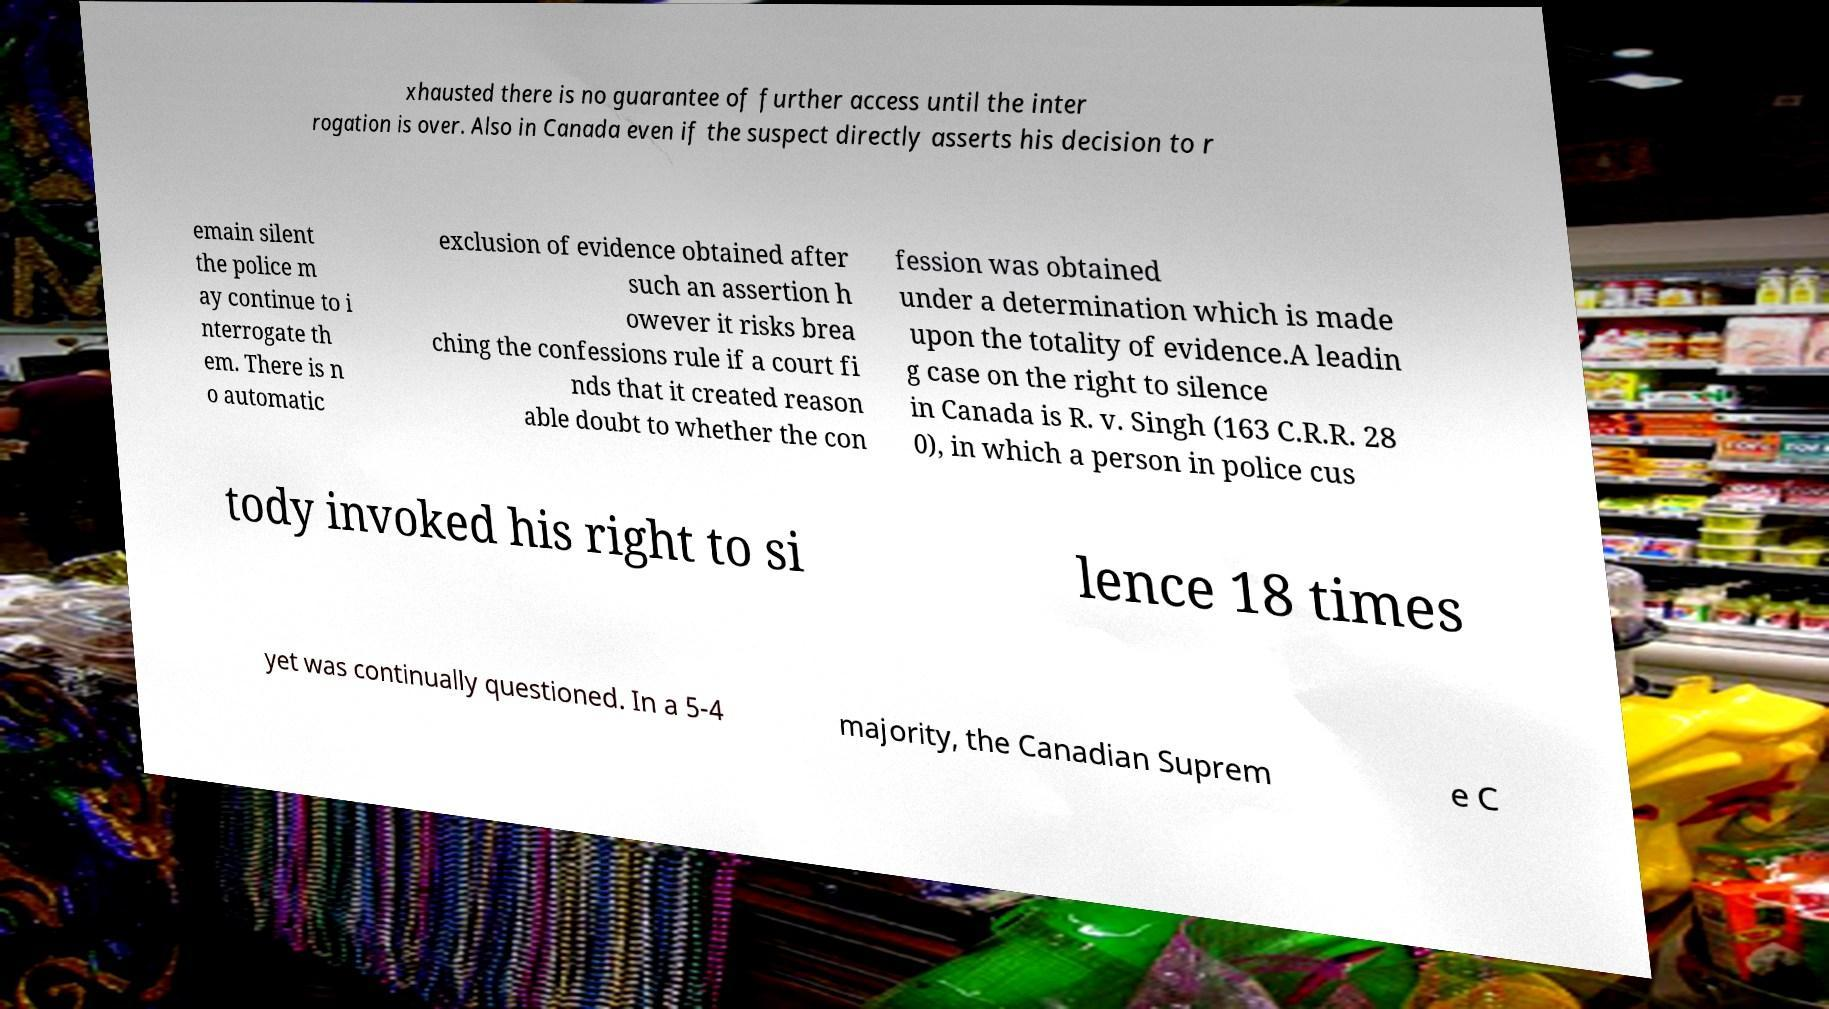Please read and relay the text visible in this image. What does it say? xhausted there is no guarantee of further access until the inter rogation is over. Also in Canada even if the suspect directly asserts his decision to r emain silent the police m ay continue to i nterrogate th em. There is n o automatic exclusion of evidence obtained after such an assertion h owever it risks brea ching the confessions rule if a court fi nds that it created reason able doubt to whether the con fession was obtained under a determination which is made upon the totality of evidence.A leadin g case on the right to silence in Canada is R. v. Singh (163 C.R.R. 28 0), in which a person in police cus tody invoked his right to si lence 18 times yet was continually questioned. In a 5-4 majority, the Canadian Suprem e C 